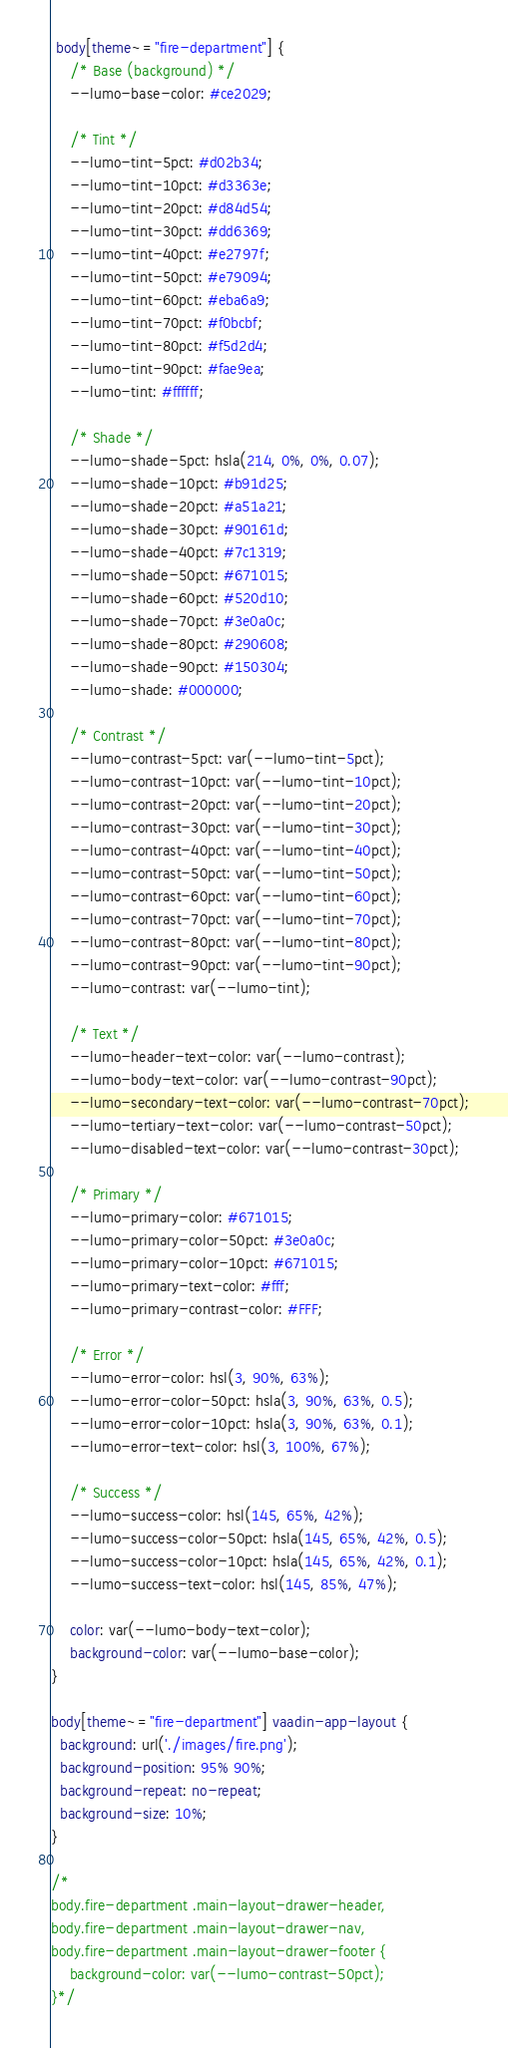Convert code to text. <code><loc_0><loc_0><loc_500><loc_500><_CSS_> body[theme~="fire-department"] {
    /* Base (background) */
    --lumo-base-color: #ce2029;

    /* Tint */
    --lumo-tint-5pct: #d02b34;
    --lumo-tint-10pct: #d3363e;
    --lumo-tint-20pct: #d84d54;
    --lumo-tint-30pct: #dd6369;
    --lumo-tint-40pct: #e2797f;
    --lumo-tint-50pct: #e79094;
    --lumo-tint-60pct: #eba6a9;
    --lumo-tint-70pct: #f0bcbf;
    --lumo-tint-80pct: #f5d2d4;
    --lumo-tint-90pct: #fae9ea;
    --lumo-tint: #ffffff;

    /* Shade */
    --lumo-shade-5pct: hsla(214, 0%, 0%, 0.07);
    --lumo-shade-10pct: #b91d25;
    --lumo-shade-20pct: #a51a21;
    --lumo-shade-30pct: #90161d;
    --lumo-shade-40pct: #7c1319;
    --lumo-shade-50pct: #671015;
    --lumo-shade-60pct: #520d10;
    --lumo-shade-70pct: #3e0a0c;
    --lumo-shade-80pct: #290608;
    --lumo-shade-90pct: #150304;
    --lumo-shade: #000000;

    /* Contrast */
    --lumo-contrast-5pct: var(--lumo-tint-5pct);
    --lumo-contrast-10pct: var(--lumo-tint-10pct);
    --lumo-contrast-20pct: var(--lumo-tint-20pct);
    --lumo-contrast-30pct: var(--lumo-tint-30pct);
    --lumo-contrast-40pct: var(--lumo-tint-40pct);
    --lumo-contrast-50pct: var(--lumo-tint-50pct);
    --lumo-contrast-60pct: var(--lumo-tint-60pct);
    --lumo-contrast-70pct: var(--lumo-tint-70pct);
    --lumo-contrast-80pct: var(--lumo-tint-80pct);
    --lumo-contrast-90pct: var(--lumo-tint-90pct);
    --lumo-contrast: var(--lumo-tint);

    /* Text */
    --lumo-header-text-color: var(--lumo-contrast);
    --lumo-body-text-color: var(--lumo-contrast-90pct);
    --lumo-secondary-text-color: var(--lumo-contrast-70pct);
    --lumo-tertiary-text-color: var(--lumo-contrast-50pct);
    --lumo-disabled-text-color: var(--lumo-contrast-30pct);

    /* Primary */
    --lumo-primary-color: #671015;
    --lumo-primary-color-50pct: #3e0a0c;
    --lumo-primary-color-10pct: #671015;
    --lumo-primary-text-color: #fff;
    --lumo-primary-contrast-color: #FFF;

    /* Error */
    --lumo-error-color: hsl(3, 90%, 63%);
    --lumo-error-color-50pct: hsla(3, 90%, 63%, 0.5);
    --lumo-error-color-10pct: hsla(3, 90%, 63%, 0.1);
    --lumo-error-text-color: hsl(3, 100%, 67%);

    /* Success */
    --lumo-success-color: hsl(145, 65%, 42%);
    --lumo-success-color-50pct: hsla(145, 65%, 42%, 0.5);
    --lumo-success-color-10pct: hsla(145, 65%, 42%, 0.1);
    --lumo-success-text-color: hsl(145, 85%, 47%);

    color: var(--lumo-body-text-color);
    background-color: var(--lumo-base-color);
}

body[theme~="fire-department"] vaadin-app-layout {
  background: url('./images/fire.png');
  background-position: 95% 90%;
  background-repeat: no-repeat;
  background-size: 10%;
}

/*
body.fire-department .main-layout-drawer-header,
body.fire-department .main-layout-drawer-nav,
body.fire-department .main-layout-drawer-footer {
    background-color: var(--lumo-contrast-50pct);
}*/
</code> 